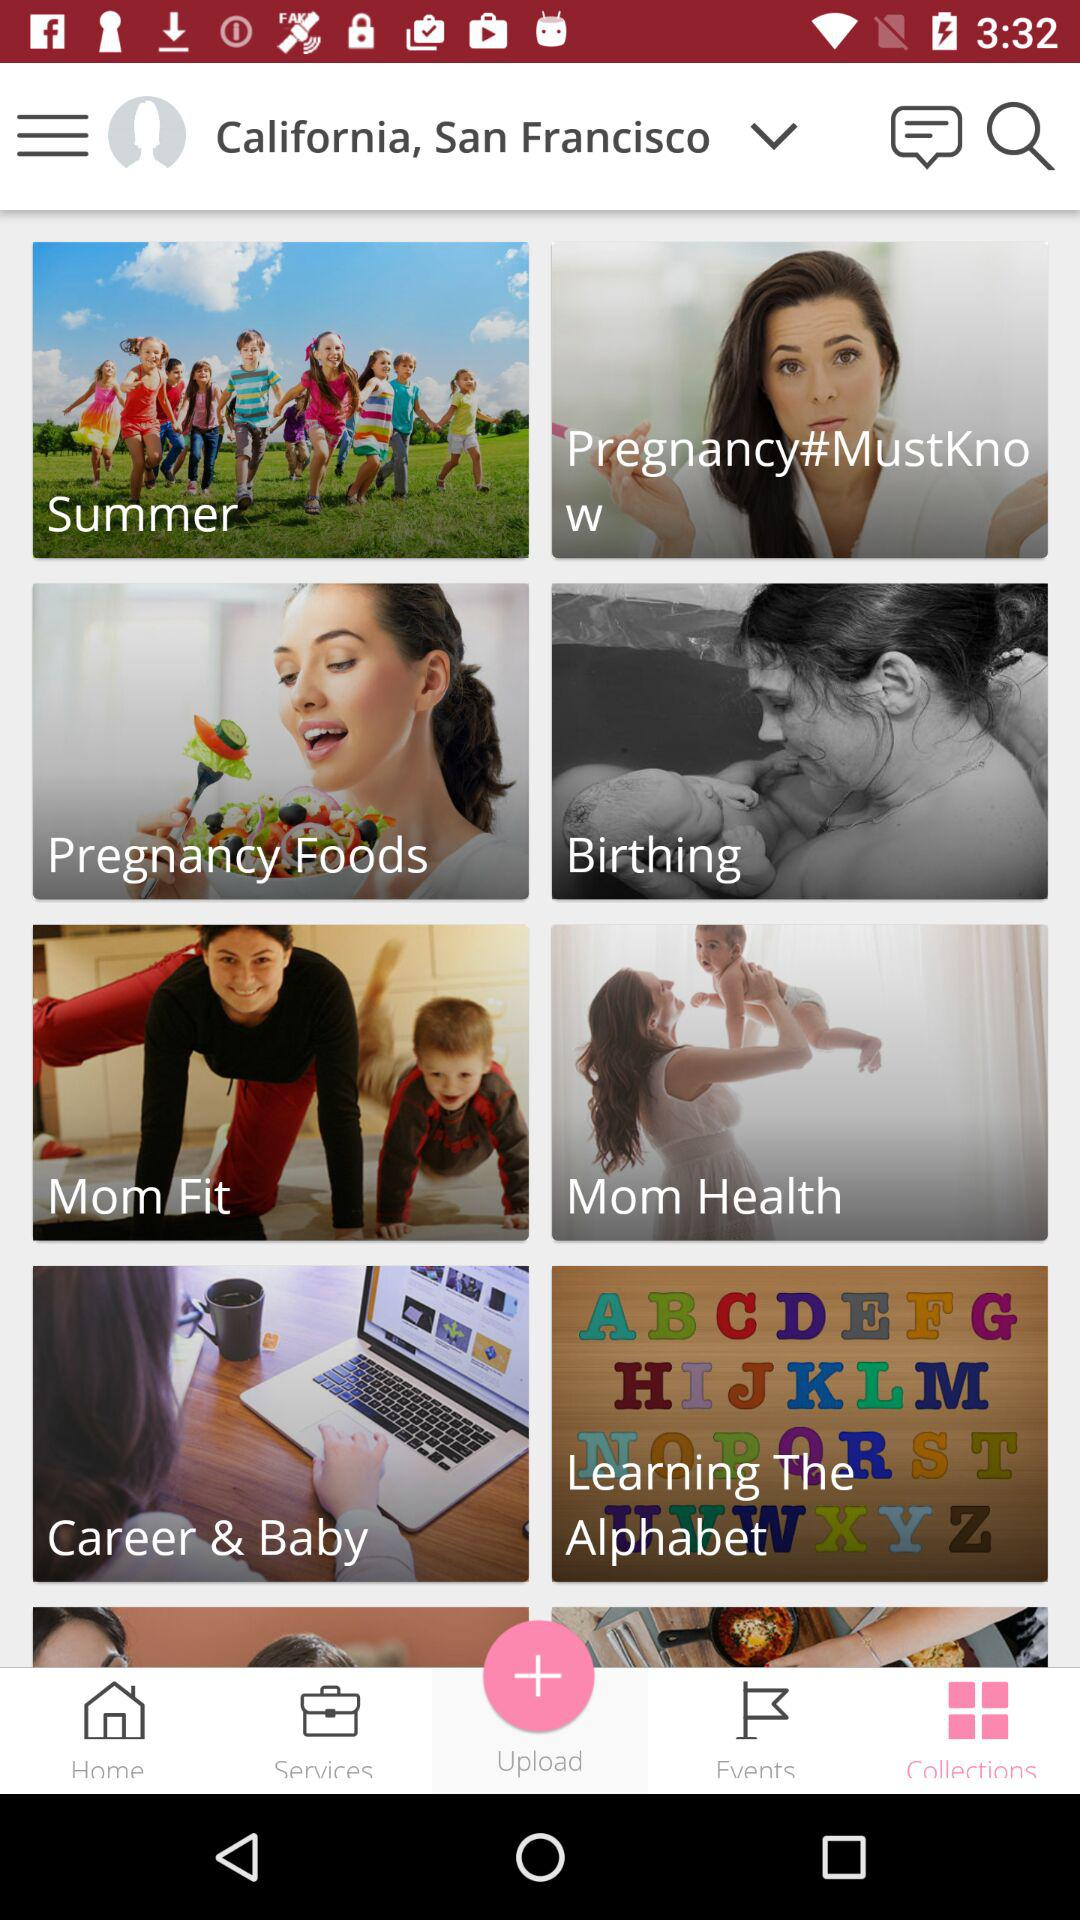Which tab has been selected? The selected tab is collections. 